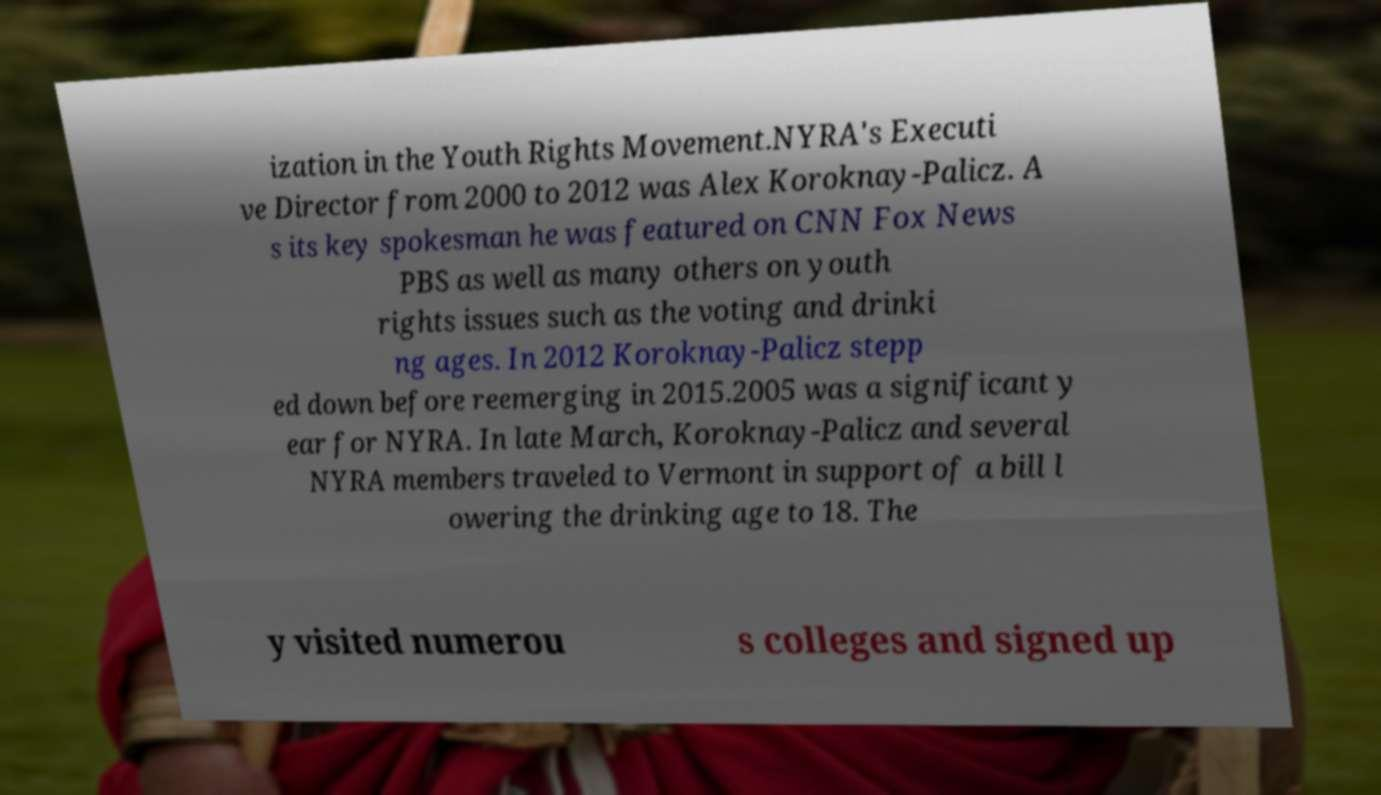Please read and relay the text visible in this image. What does it say? ization in the Youth Rights Movement.NYRA's Executi ve Director from 2000 to 2012 was Alex Koroknay-Palicz. A s its key spokesman he was featured on CNN Fox News PBS as well as many others on youth rights issues such as the voting and drinki ng ages. In 2012 Koroknay-Palicz stepp ed down before reemerging in 2015.2005 was a significant y ear for NYRA. In late March, Koroknay-Palicz and several NYRA members traveled to Vermont in support of a bill l owering the drinking age to 18. The y visited numerou s colleges and signed up 